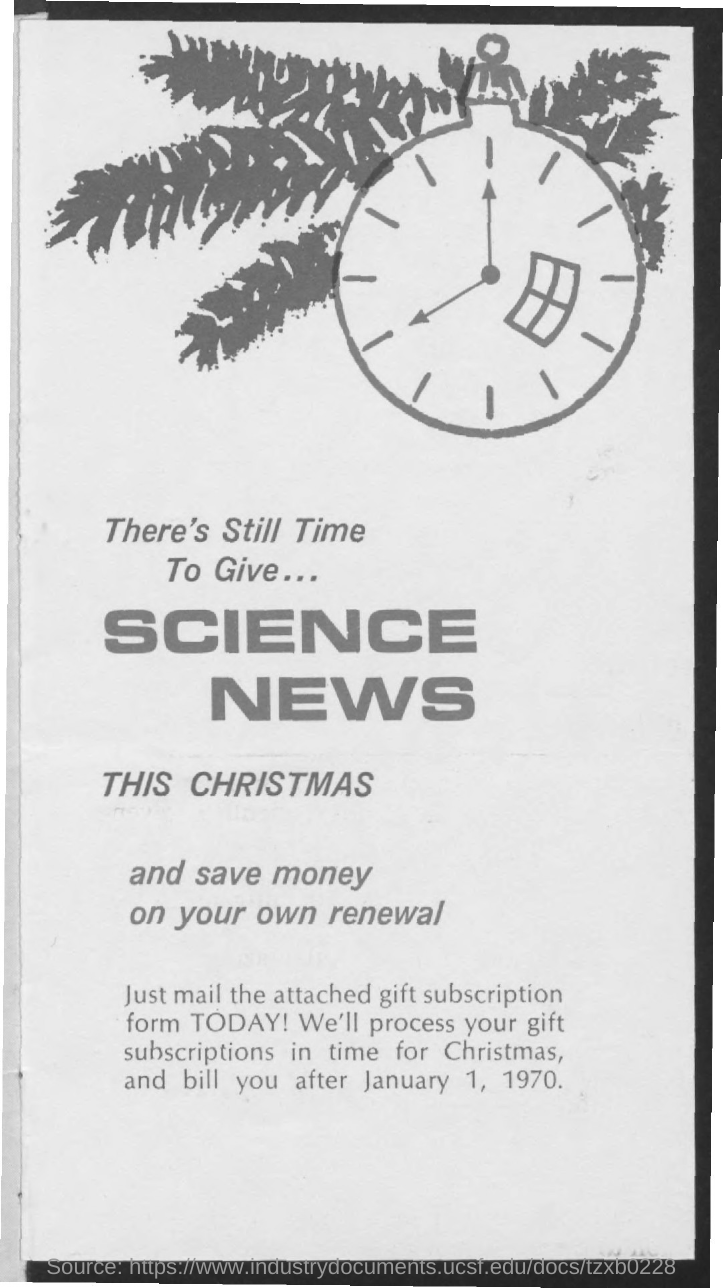Outline some significant characteristics in this image. The document mentions that the date is January 1, 1970. 